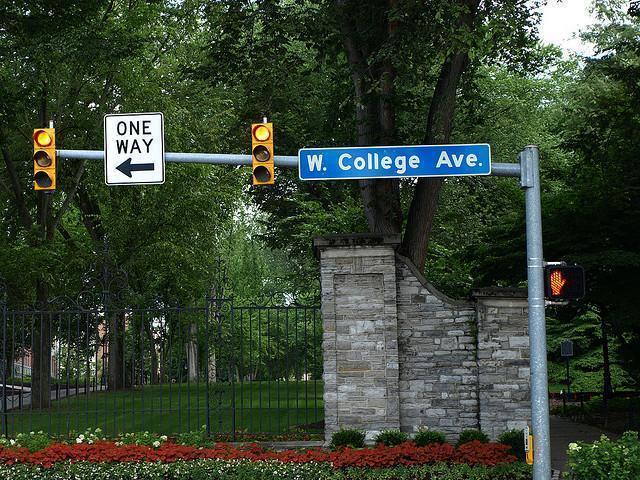What color is the light shown on top of the traffic lights of College Avenue?
Choose the right answer from the provided options to respond to the question.
Options: Blue, yellow, red, green. Yellow. 